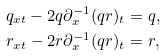Convert formula to latex. <formula><loc_0><loc_0><loc_500><loc_500>& q _ { x t } - 2 q \partial ^ { - 1 } _ { x } ( q r ) _ { t } = q , \\ & r _ { x t } - 2 r \partial ^ { - 1 } _ { x } ( q r ) _ { t } = r ,</formula> 